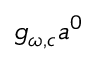<formula> <loc_0><loc_0><loc_500><loc_500>g _ { \omega , c } a ^ { 0 }</formula> 